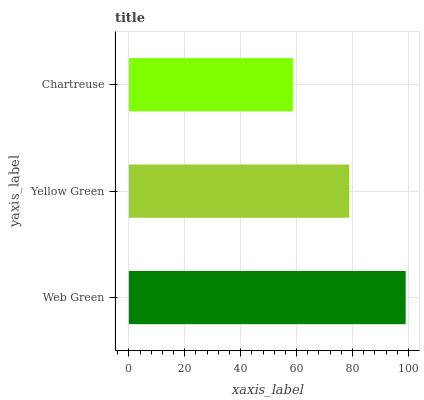Is Chartreuse the minimum?
Answer yes or no. Yes. Is Web Green the maximum?
Answer yes or no. Yes. Is Yellow Green the minimum?
Answer yes or no. No. Is Yellow Green the maximum?
Answer yes or no. No. Is Web Green greater than Yellow Green?
Answer yes or no. Yes. Is Yellow Green less than Web Green?
Answer yes or no. Yes. Is Yellow Green greater than Web Green?
Answer yes or no. No. Is Web Green less than Yellow Green?
Answer yes or no. No. Is Yellow Green the high median?
Answer yes or no. Yes. Is Yellow Green the low median?
Answer yes or no. Yes. Is Web Green the high median?
Answer yes or no. No. Is Chartreuse the low median?
Answer yes or no. No. 